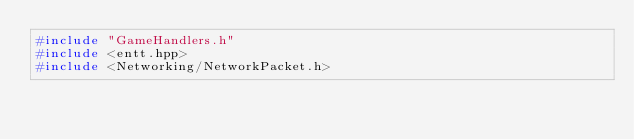Convert code to text. <code><loc_0><loc_0><loc_500><loc_500><_C++_>#include "GameHandlers.h"
#include <entt.hpp>
#include <Networking/NetworkPacket.h></code> 